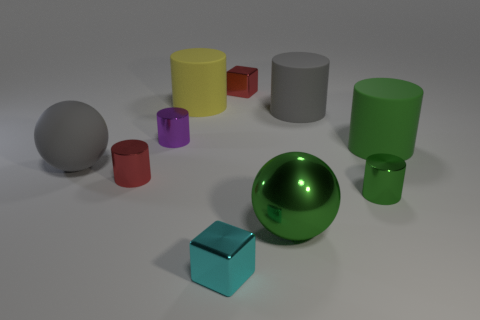Are there more tiny red shiny cylinders that are behind the green matte thing than green things behind the large yellow thing?
Ensure brevity in your answer.  No. There is a rubber object that is the same color as the matte ball; what size is it?
Keep it short and to the point. Large. There is a purple object; is it the same size as the gray matte thing that is to the right of the cyan cube?
Give a very brief answer. No. How many cubes are either small cyan shiny things or tiny blue things?
Make the answer very short. 1. The purple cylinder that is made of the same material as the red cylinder is what size?
Keep it short and to the point. Small. There is a block in front of the large gray rubber cylinder; does it have the same size as the red thing that is in front of the gray cylinder?
Provide a short and direct response. Yes. What number of things are either green metal spheres or tiny green cylinders?
Provide a succinct answer. 2. The tiny green metallic object has what shape?
Give a very brief answer. Cylinder. What is the size of the gray object that is the same shape as the green matte thing?
Ensure brevity in your answer.  Large. There is a gray rubber object in front of the big gray rubber object that is behind the purple metal cylinder; what is its size?
Make the answer very short. Large. 